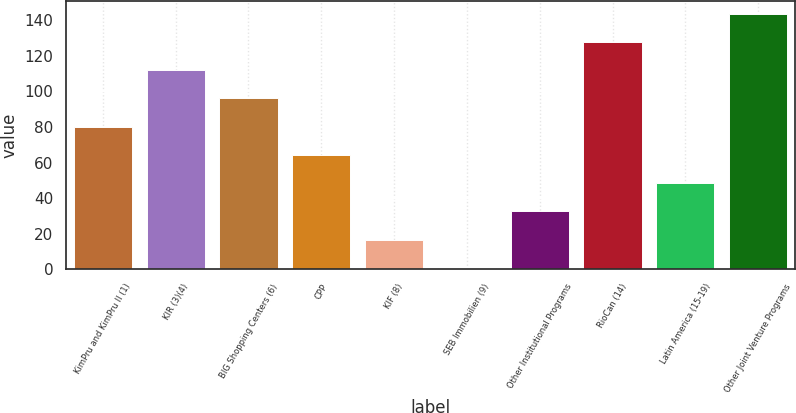Convert chart to OTSL. <chart><loc_0><loc_0><loc_500><loc_500><bar_chart><fcel>KimPru and KimPru II (1)<fcel>KIR (3)(4)<fcel>BIG Shopping Centers (6)<fcel>CPP<fcel>KIF (8)<fcel>SEB Immobilien (9)<fcel>Other Institutional Programs<fcel>RioCan (14)<fcel>Latin America (15-19)<fcel>Other Joint Venture Programs<nl><fcel>80.2<fcel>111.96<fcel>96.08<fcel>64.32<fcel>16.68<fcel>0.8<fcel>32.56<fcel>127.84<fcel>48.44<fcel>143.72<nl></chart> 